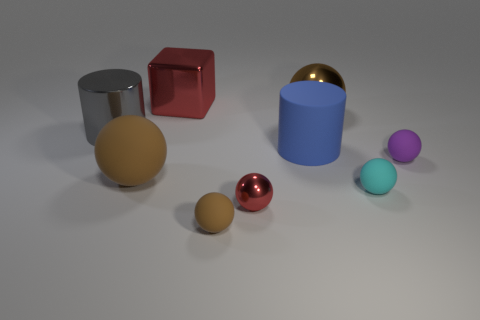There is a small object left of the small red ball; is it the same shape as the brown matte object behind the tiny cyan object?
Provide a succinct answer. Yes. The big object that is on the left side of the large brown object on the left side of the red block is what color?
Your answer should be very brief. Gray. How many balls are either large brown things or gray matte things?
Your answer should be compact. 2. There is a big cylinder that is to the left of the metal thing in front of the shiny cylinder; what number of small cyan balls are in front of it?
Provide a succinct answer. 1. There is a shiny thing that is the same color as the small metal sphere; what is its size?
Your answer should be very brief. Large. Is there a brown thing that has the same material as the big gray object?
Your answer should be compact. Yes. Are the red sphere and the tiny purple thing made of the same material?
Give a very brief answer. No. How many large spheres are behind the shiny ball that is to the left of the brown metallic object?
Give a very brief answer. 2. How many gray objects are tiny spheres or matte cylinders?
Give a very brief answer. 0. The red object behind the big shiny thing on the right side of the small brown matte object that is in front of the big cube is what shape?
Keep it short and to the point. Cube. 